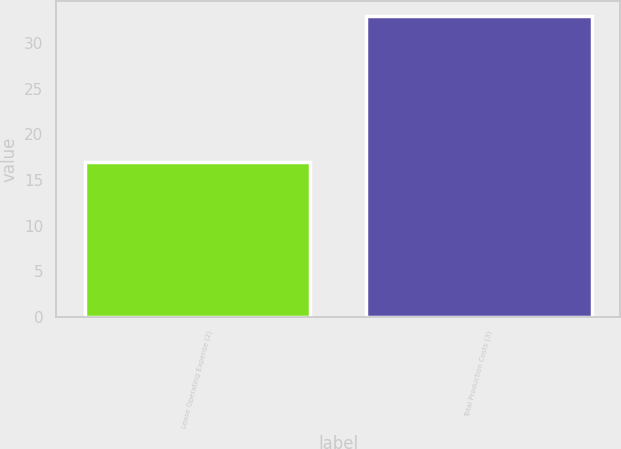Convert chart to OTSL. <chart><loc_0><loc_0><loc_500><loc_500><bar_chart><fcel>Lease Operating Expense (2)<fcel>Total Production Costs (3)<nl><fcel>17<fcel>33<nl></chart> 